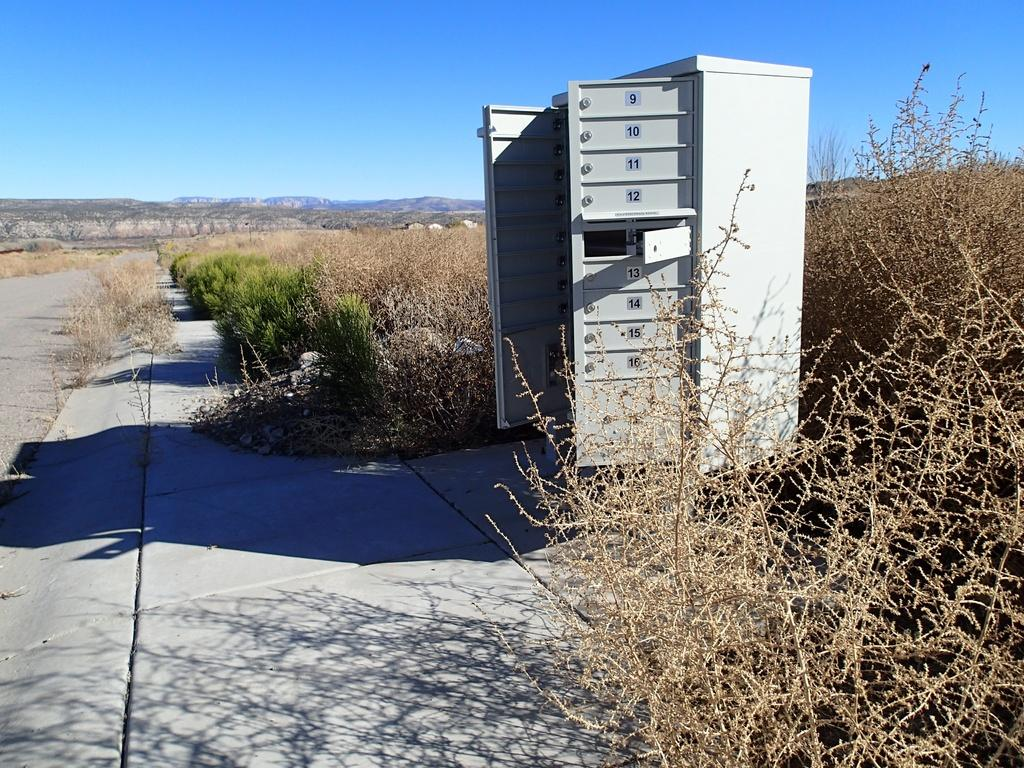What type of living organisms can be seen in the image? Plants can be seen in the image. What is the color of the plants in the image? The plants are green. Are there any dried plants in the image? Yes, there are dried plants in the image. What is visible in the background of the image? The sky is visible in the background of the image. What is the color of the sky in the image? The sky is blue. What object made of metal can be seen in the image? There is an iron box in the image. What type of vest is the station wearing in the image? There is no station or vest present in the image. Can you describe the arm of the person holding the plant in the image? There is no person holding a plant in the image, so it's not possible to describe their arm. 